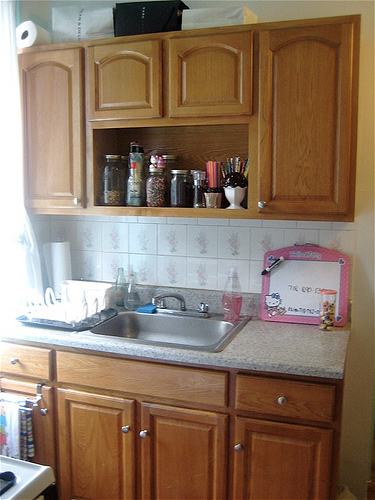<image>
Is there a sink under the soap? Yes. The sink is positioned underneath the soap, with the soap above it in the vertical space. 